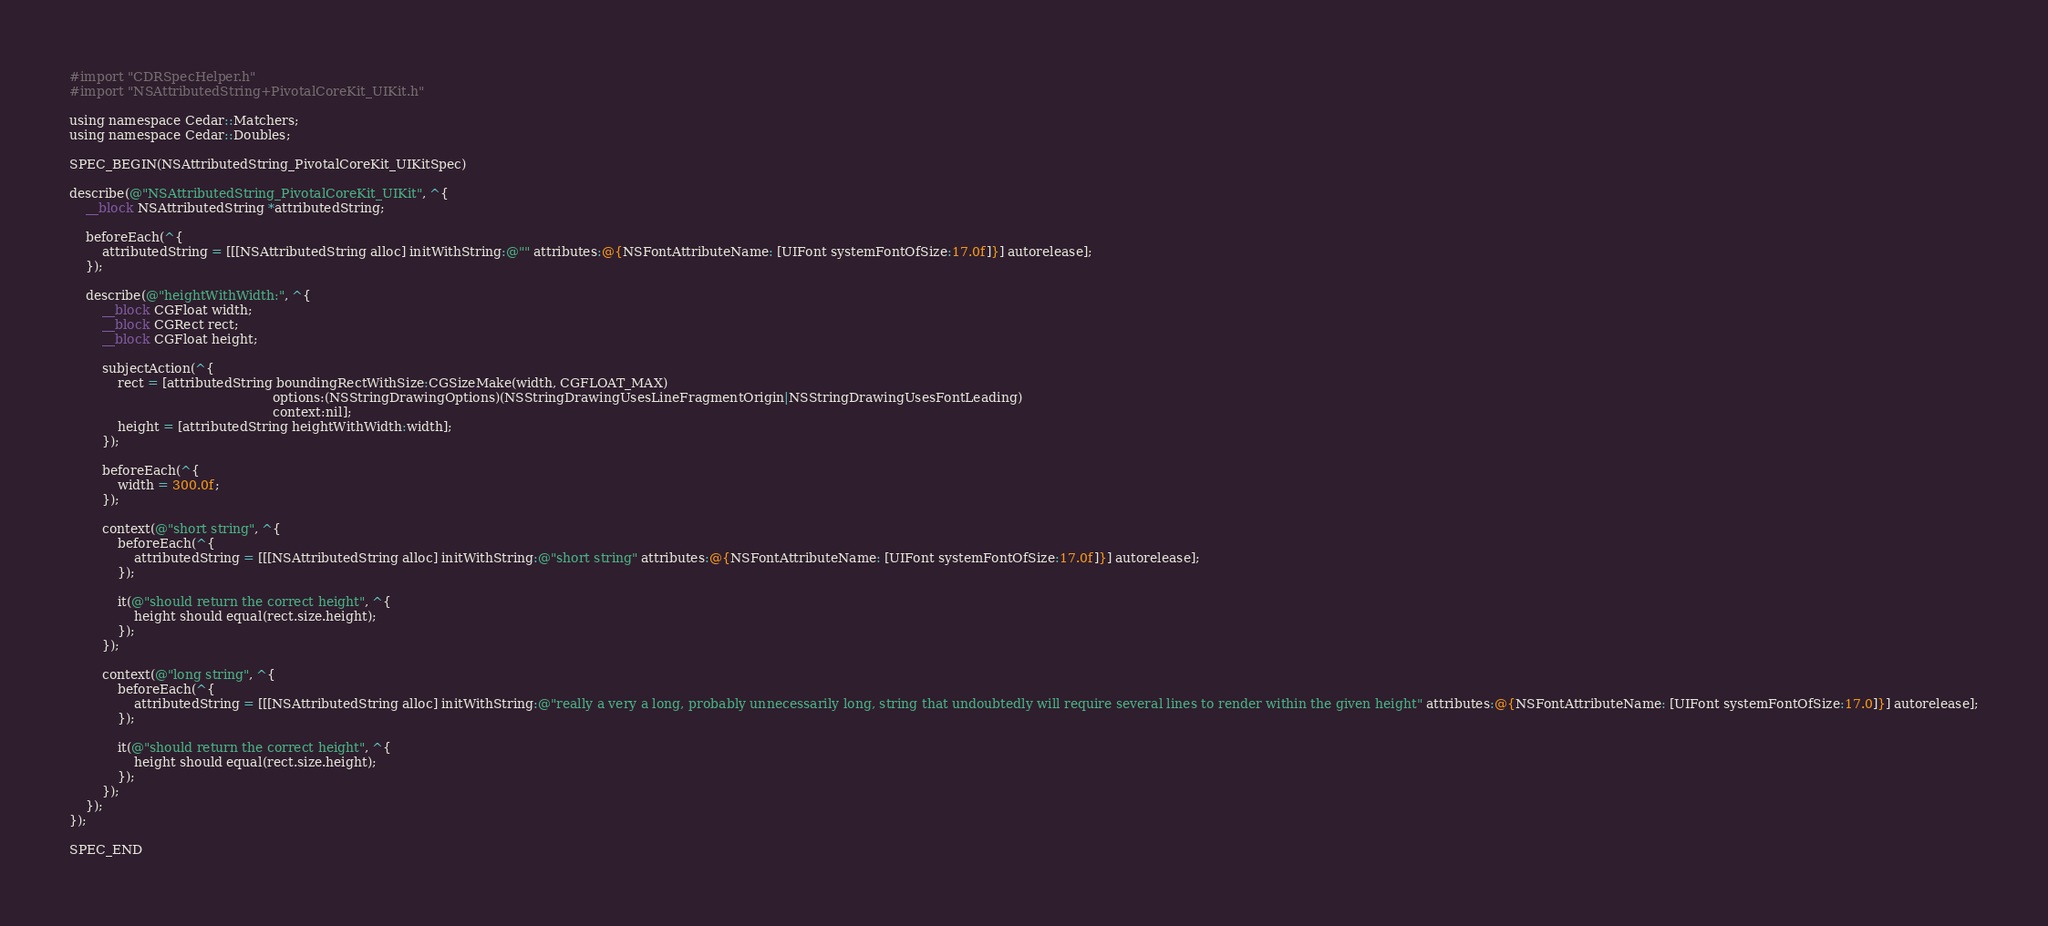Convert code to text. <code><loc_0><loc_0><loc_500><loc_500><_ObjectiveC_>#import "CDRSpecHelper.h"
#import "NSAttributedString+PivotalCoreKit_UIKit.h"

using namespace Cedar::Matchers;
using namespace Cedar::Doubles;

SPEC_BEGIN(NSAttributedString_PivotalCoreKit_UIKitSpec)

describe(@"NSAttributedString_PivotalCoreKit_UIKit", ^{
    __block NSAttributedString *attributedString;

    beforeEach(^{
        attributedString = [[[NSAttributedString alloc] initWithString:@"" attributes:@{NSFontAttributeName: [UIFont systemFontOfSize:17.0f]}] autorelease];
    });

    describe(@"heightWithWidth:", ^{
        __block CGFloat width;
        __block CGRect rect;
        __block CGFloat height;

        subjectAction(^{
            rect = [attributedString boundingRectWithSize:CGSizeMake(width, CGFLOAT_MAX)
                                                  options:(NSStringDrawingOptions)(NSStringDrawingUsesLineFragmentOrigin|NSStringDrawingUsesFontLeading)
                                                  context:nil];
            height = [attributedString heightWithWidth:width];
        });

        beforeEach(^{
            width = 300.0f;
        });

        context(@"short string", ^{
            beforeEach(^{
                attributedString = [[[NSAttributedString alloc] initWithString:@"short string" attributes:@{NSFontAttributeName: [UIFont systemFontOfSize:17.0f]}] autorelease];
            });

            it(@"should return the correct height", ^{
                height should equal(rect.size.height);
            });
        });

        context(@"long string", ^{
            beforeEach(^{
                attributedString = [[[NSAttributedString alloc] initWithString:@"really a very a long, probably unnecessarily long, string that undoubtedly will require several lines to render within the given height" attributes:@{NSFontAttributeName: [UIFont systemFontOfSize:17.0]}] autorelease];
            });

            it(@"should return the correct height", ^{
                height should equal(rect.size.height);
            });
        });
    });
});

SPEC_END
</code> 